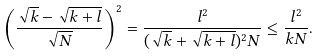<formula> <loc_0><loc_0><loc_500><loc_500>\left ( \frac { \sqrt { k } - \sqrt { k + l } } { \sqrt { N } } \right ) ^ { 2 } = \frac { l ^ { 2 } } { ( \sqrt { k } + \sqrt { k + l } ) ^ { 2 } N } \leq \frac { l ^ { 2 } } { k N } .</formula> 